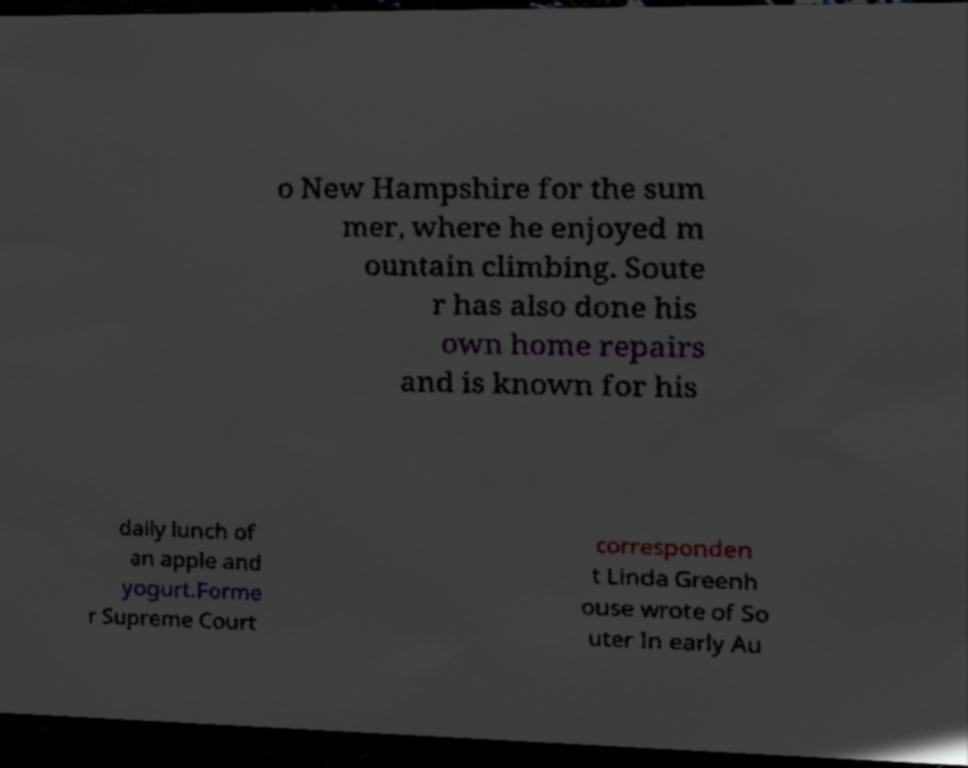Can you accurately transcribe the text from the provided image for me? o New Hampshire for the sum mer, where he enjoyed m ountain climbing. Soute r has also done his own home repairs and is known for his daily lunch of an apple and yogurt.Forme r Supreme Court corresponden t Linda Greenh ouse wrote of So uter In early Au 